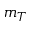<formula> <loc_0><loc_0><loc_500><loc_500>m _ { T }</formula> 